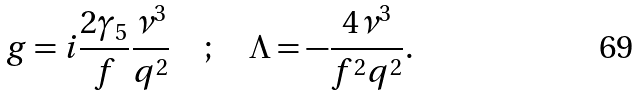Convert formula to latex. <formula><loc_0><loc_0><loc_500><loc_500>g = i \frac { 2 \gamma _ { 5 } } { f } \frac { \nu ^ { 3 } } { q ^ { 2 } } \quad ; \quad \Lambda = - \frac { 4 \nu ^ { 3 } } { f ^ { 2 } q ^ { 2 } } .</formula> 